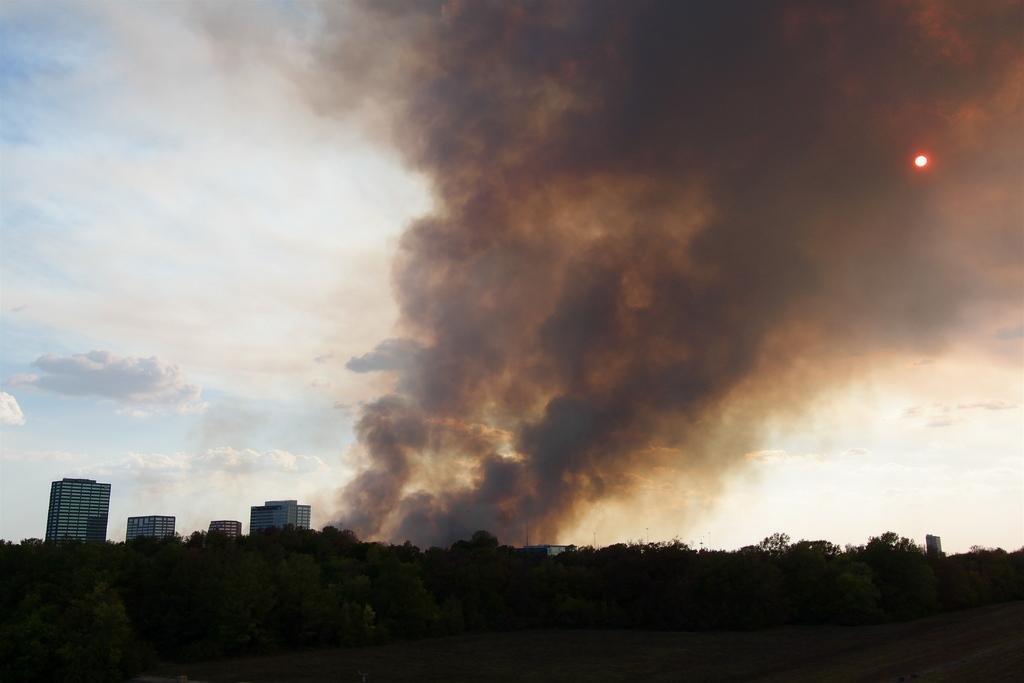What is happening in the image? Something is burning in the image, and smoke is visible. What can be seen in the background of the image? The background of the image is the sky. What type of stitch is being used to repair the volcano in the image? There is no volcano or stitching present in the image. Is the alarm going off in the image? There is no alarm present in the image. 